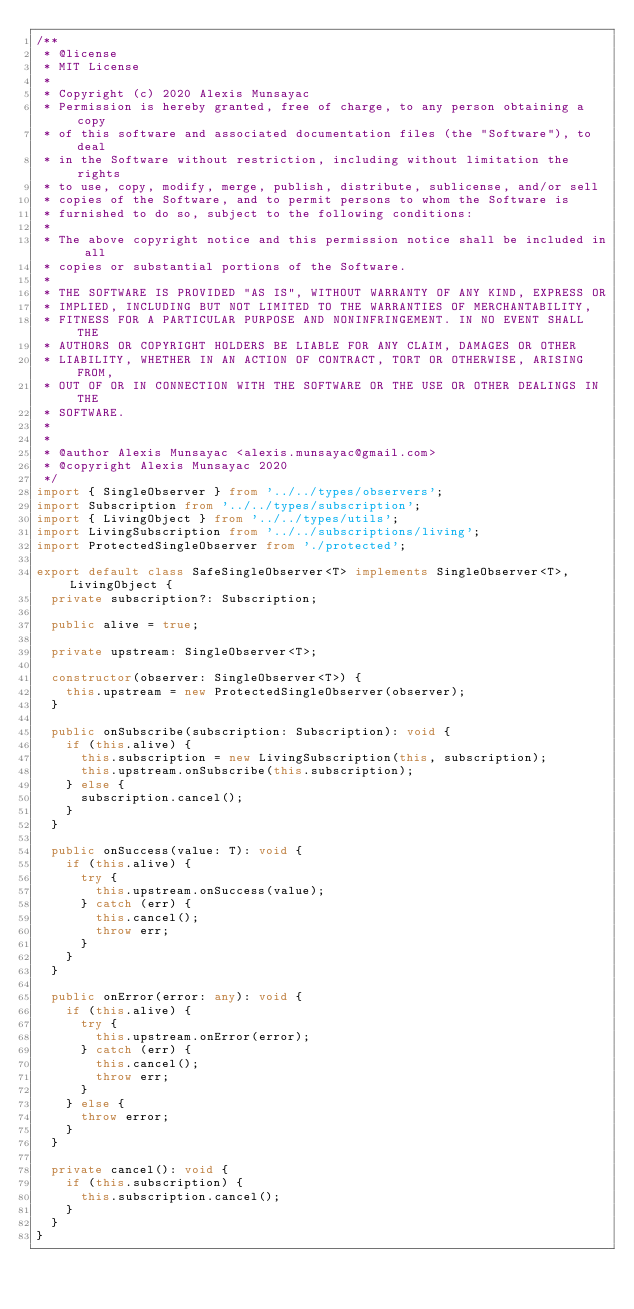<code> <loc_0><loc_0><loc_500><loc_500><_TypeScript_>/**
 * @license
 * MIT License
 *
 * Copyright (c) 2020 Alexis Munsayac
 * Permission is hereby granted, free of charge, to any person obtaining a copy
 * of this software and associated documentation files (the "Software"), to deal
 * in the Software without restriction, including without limitation the rights
 * to use, copy, modify, merge, publish, distribute, sublicense, and/or sell
 * copies of the Software, and to permit persons to whom the Software is
 * furnished to do so, subject to the following conditions:
 *
 * The above copyright notice and this permission notice shall be included in all
 * copies or substantial portions of the Software.
 *
 * THE SOFTWARE IS PROVIDED "AS IS", WITHOUT WARRANTY OF ANY KIND, EXPRESS OR
 * IMPLIED, INCLUDING BUT NOT LIMITED TO THE WARRANTIES OF MERCHANTABILITY,
 * FITNESS FOR A PARTICULAR PURPOSE AND NONINFRINGEMENT. IN NO EVENT SHALL THE
 * AUTHORS OR COPYRIGHT HOLDERS BE LIABLE FOR ANY CLAIM, DAMAGES OR OTHER
 * LIABILITY, WHETHER IN AN ACTION OF CONTRACT, TORT OR OTHERWISE, ARISING FROM,
 * OUT OF OR IN CONNECTION WITH THE SOFTWARE OR THE USE OR OTHER DEALINGS IN THE
 * SOFTWARE.
 *
 *
 * @author Alexis Munsayac <alexis.munsayac@gmail.com>
 * @copyright Alexis Munsayac 2020
 */
import { SingleObserver } from '../../types/observers';
import Subscription from '../../types/subscription';
import { LivingObject } from '../../types/utils';
import LivingSubscription from '../../subscriptions/living';
import ProtectedSingleObserver from './protected';

export default class SafeSingleObserver<T> implements SingleObserver<T>, LivingObject {
  private subscription?: Subscription;

  public alive = true;

  private upstream: SingleObserver<T>;

  constructor(observer: SingleObserver<T>) {
    this.upstream = new ProtectedSingleObserver(observer);
  }

  public onSubscribe(subscription: Subscription): void {
    if (this.alive) {
      this.subscription = new LivingSubscription(this, subscription);
      this.upstream.onSubscribe(this.subscription);
    } else {
      subscription.cancel();
    }
  }

  public onSuccess(value: T): void {
    if (this.alive) {
      try {
        this.upstream.onSuccess(value);
      } catch (err) {
        this.cancel();
        throw err;
      }
    }
  }

  public onError(error: any): void {
    if (this.alive) {
      try {
        this.upstream.onError(error);
      } catch (err) {
        this.cancel();
        throw err;
      }
    } else {
      throw error;
    }
  }

  private cancel(): void {
    if (this.subscription) {
      this.subscription.cancel();
    }
  }
}
</code> 